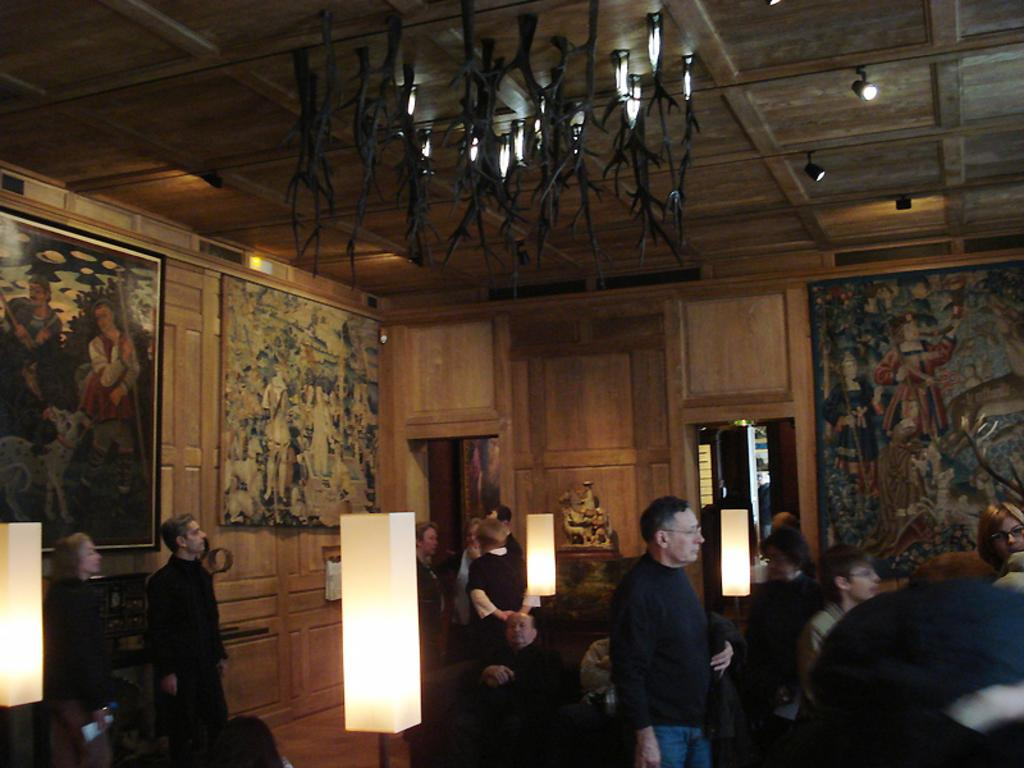What type of material is used for the wall in the image? The wall in the image is made of wood. What can be seen hanging on the wooden wall? There are pictures on the wooden wall. What type of lighting is present in the image? Lights are attached to the ceiling, and they are visible in the image. What kind of artwork is present in the image? There is a sculpture in the image. Are there any people present in the image? Yes, there are people in the image. Can you see any cobwebs in the image? There is no mention of cobwebs in the provided facts, and therefore we cannot determine if any are present in the image. Are the people in the image having an argument? There is no indication of an argument in the image, as the provided facts only mention the presence of people. 